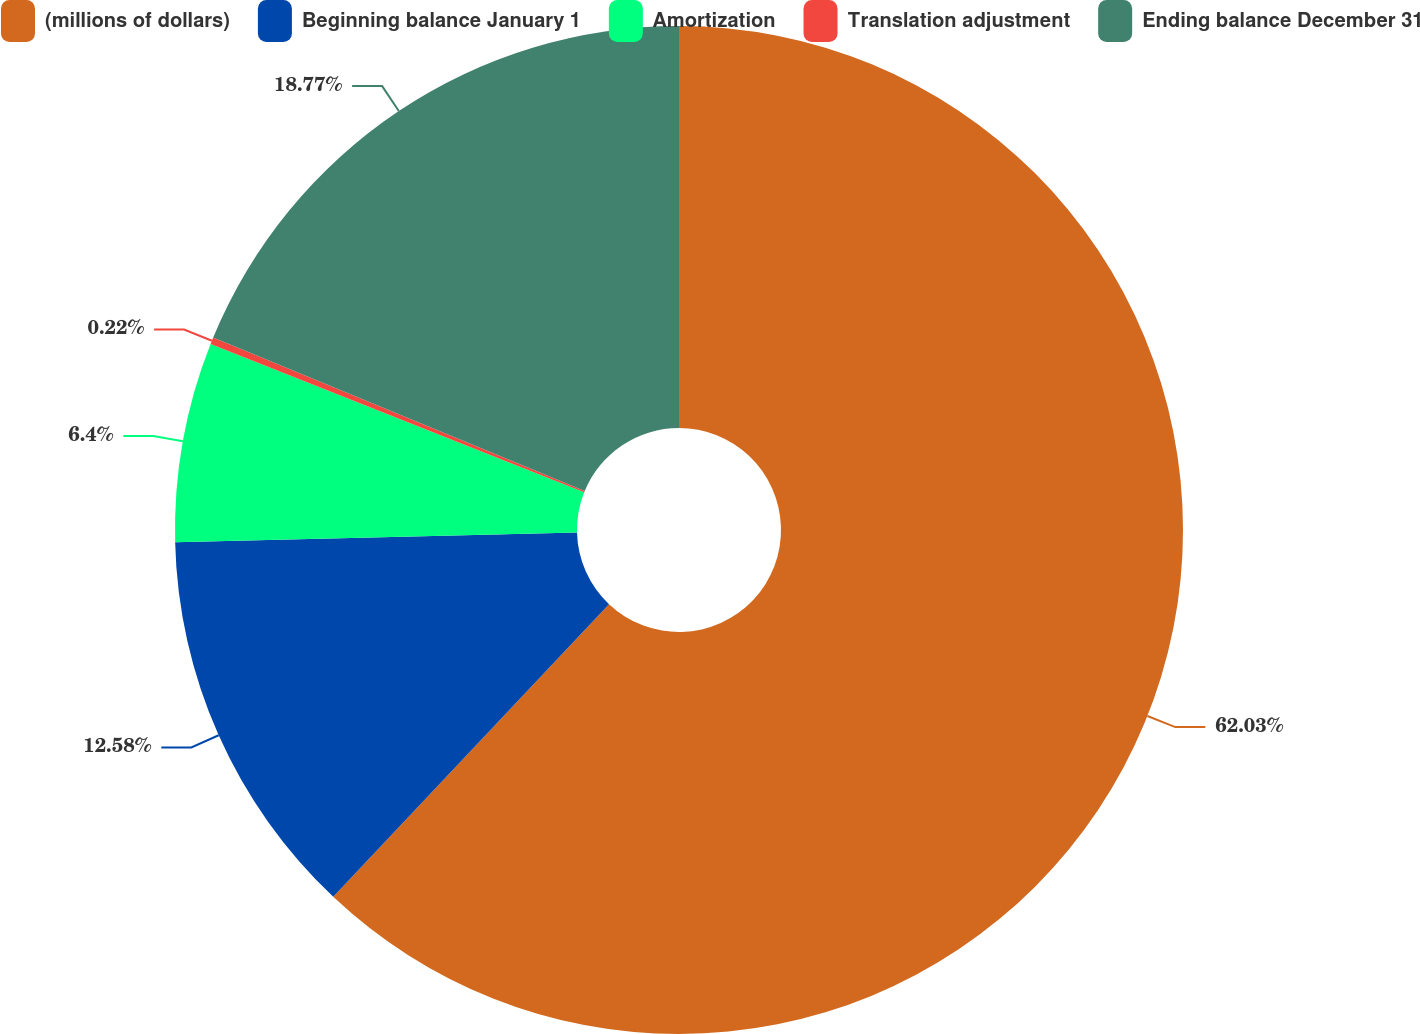Convert chart. <chart><loc_0><loc_0><loc_500><loc_500><pie_chart><fcel>(millions of dollars)<fcel>Beginning balance January 1<fcel>Amortization<fcel>Translation adjustment<fcel>Ending balance December 31<nl><fcel>62.02%<fcel>12.58%<fcel>6.4%<fcel>0.22%<fcel>18.76%<nl></chart> 